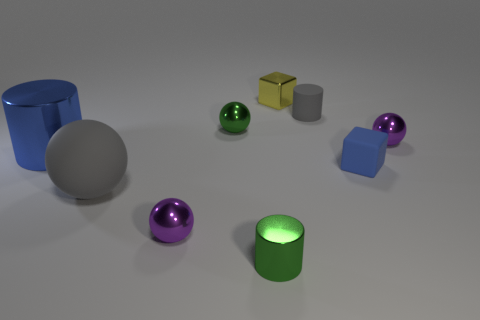There is a rubber object that is the same color as the rubber sphere; what is its size?
Ensure brevity in your answer.  Small. What shape is the rubber object that is the same color as the big cylinder?
Provide a short and direct response. Cube. What number of things are either blue cylinders in front of the yellow metal thing or large objects behind the gray matte sphere?
Give a very brief answer. 1. Are there fewer big brown blocks than tiny green metallic objects?
Offer a terse response. Yes. What number of objects are either gray spheres or purple things?
Provide a short and direct response. 3. Do the tiny yellow object and the blue rubber object have the same shape?
Your answer should be compact. Yes. Is the size of the sphere that is on the right side of the green metal cylinder the same as the blue thing that is behind the tiny matte cube?
Your answer should be compact. No. There is a cylinder that is to the right of the big blue thing and behind the small green metal cylinder; what is its material?
Provide a succinct answer. Rubber. Is there anything else of the same color as the large metal cylinder?
Provide a succinct answer. Yes. Are there fewer small green cylinders that are left of the gray matte ball than big red metallic objects?
Your response must be concise. No. 